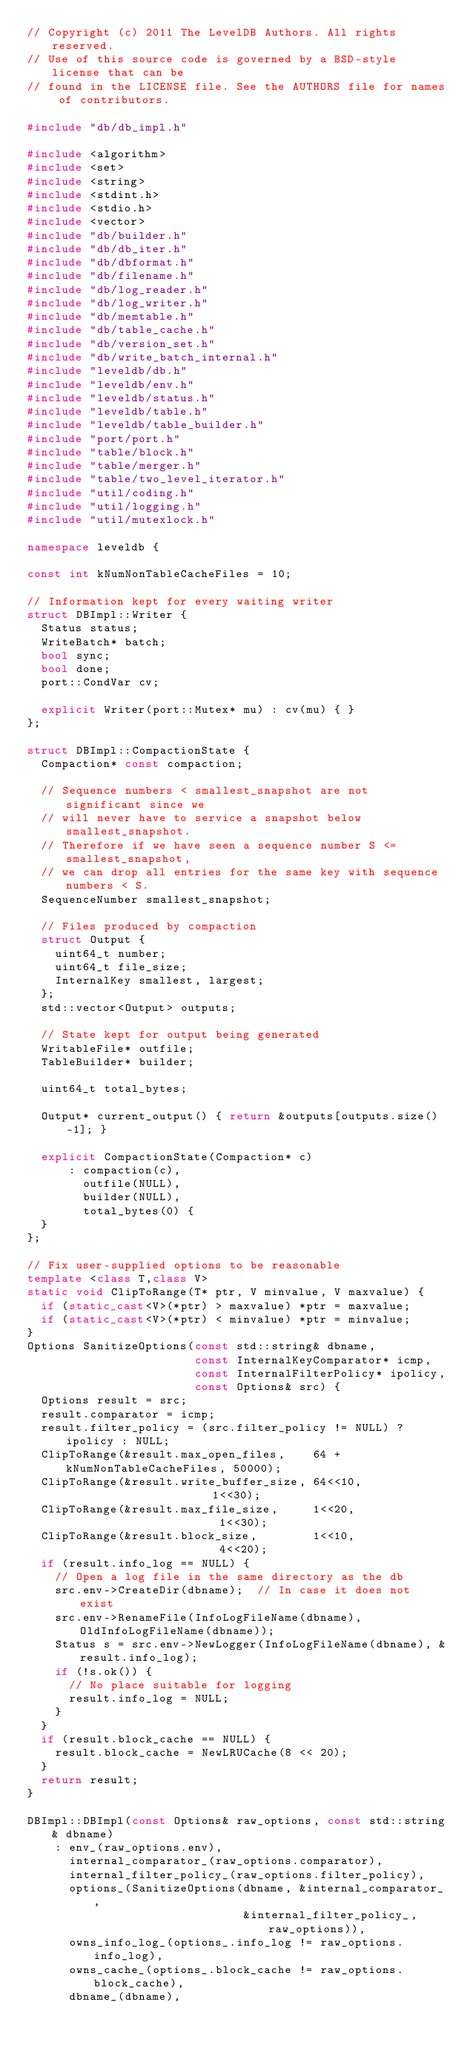Convert code to text. <code><loc_0><loc_0><loc_500><loc_500><_C++_>// Copyright (c) 2011 The LevelDB Authors. All rights reserved.
// Use of this source code is governed by a BSD-style license that can be
// found in the LICENSE file. See the AUTHORS file for names of contributors.

#include "db/db_impl.h"

#include <algorithm>
#include <set>
#include <string>
#include <stdint.h>
#include <stdio.h>
#include <vector>
#include "db/builder.h"
#include "db/db_iter.h"
#include "db/dbformat.h"
#include "db/filename.h"
#include "db/log_reader.h"
#include "db/log_writer.h"
#include "db/memtable.h"
#include "db/table_cache.h"
#include "db/version_set.h"
#include "db/write_batch_internal.h"
#include "leveldb/db.h"
#include "leveldb/env.h"
#include "leveldb/status.h"
#include "leveldb/table.h"
#include "leveldb/table_builder.h"
#include "port/port.h"
#include "table/block.h"
#include "table/merger.h"
#include "table/two_level_iterator.h"
#include "util/coding.h"
#include "util/logging.h"
#include "util/mutexlock.h"

namespace leveldb {

const int kNumNonTableCacheFiles = 10;

// Information kept for every waiting writer
struct DBImpl::Writer {
  Status status;
  WriteBatch* batch;
  bool sync;
  bool done;
  port::CondVar cv;

  explicit Writer(port::Mutex* mu) : cv(mu) { }
};

struct DBImpl::CompactionState {
  Compaction* const compaction;

  // Sequence numbers < smallest_snapshot are not significant since we
  // will never have to service a snapshot below smallest_snapshot.
  // Therefore if we have seen a sequence number S <= smallest_snapshot,
  // we can drop all entries for the same key with sequence numbers < S.
  SequenceNumber smallest_snapshot;

  // Files produced by compaction
  struct Output {
    uint64_t number;
    uint64_t file_size;
    InternalKey smallest, largest;
  };
  std::vector<Output> outputs;

  // State kept for output being generated
  WritableFile* outfile;
  TableBuilder* builder;

  uint64_t total_bytes;

  Output* current_output() { return &outputs[outputs.size()-1]; }

  explicit CompactionState(Compaction* c)
      : compaction(c),
        outfile(NULL),
        builder(NULL),
        total_bytes(0) {
  }
};

// Fix user-supplied options to be reasonable
template <class T,class V>
static void ClipToRange(T* ptr, V minvalue, V maxvalue) {
  if (static_cast<V>(*ptr) > maxvalue) *ptr = maxvalue;
  if (static_cast<V>(*ptr) < minvalue) *ptr = minvalue;
}
Options SanitizeOptions(const std::string& dbname,
                        const InternalKeyComparator* icmp,
                        const InternalFilterPolicy* ipolicy,
                        const Options& src) {
  Options result = src;
  result.comparator = icmp;
  result.filter_policy = (src.filter_policy != NULL) ? ipolicy : NULL;
  ClipToRange(&result.max_open_files,    64 + kNumNonTableCacheFiles, 50000);
  ClipToRange(&result.write_buffer_size, 64<<10,                      1<<30);
  ClipToRange(&result.max_file_size,     1<<20,                       1<<30);
  ClipToRange(&result.block_size,        1<<10,                       4<<20);
  if (result.info_log == NULL) {
    // Open a log file in the same directory as the db
    src.env->CreateDir(dbname);  // In case it does not exist
    src.env->RenameFile(InfoLogFileName(dbname), OldInfoLogFileName(dbname));
    Status s = src.env->NewLogger(InfoLogFileName(dbname), &result.info_log);
    if (!s.ok()) {
      // No place suitable for logging
      result.info_log = NULL;
    }
  }
  if (result.block_cache == NULL) {
    result.block_cache = NewLRUCache(8 << 20);
  }
  return result;
}

DBImpl::DBImpl(const Options& raw_options, const std::string& dbname)
    : env_(raw_options.env),
      internal_comparator_(raw_options.comparator),
      internal_filter_policy_(raw_options.filter_policy),
      options_(SanitizeOptions(dbname, &internal_comparator_,
                               &internal_filter_policy_, raw_options)),
      owns_info_log_(options_.info_log != raw_options.info_log),
      owns_cache_(options_.block_cache != raw_options.block_cache),
      dbname_(dbname),</code> 